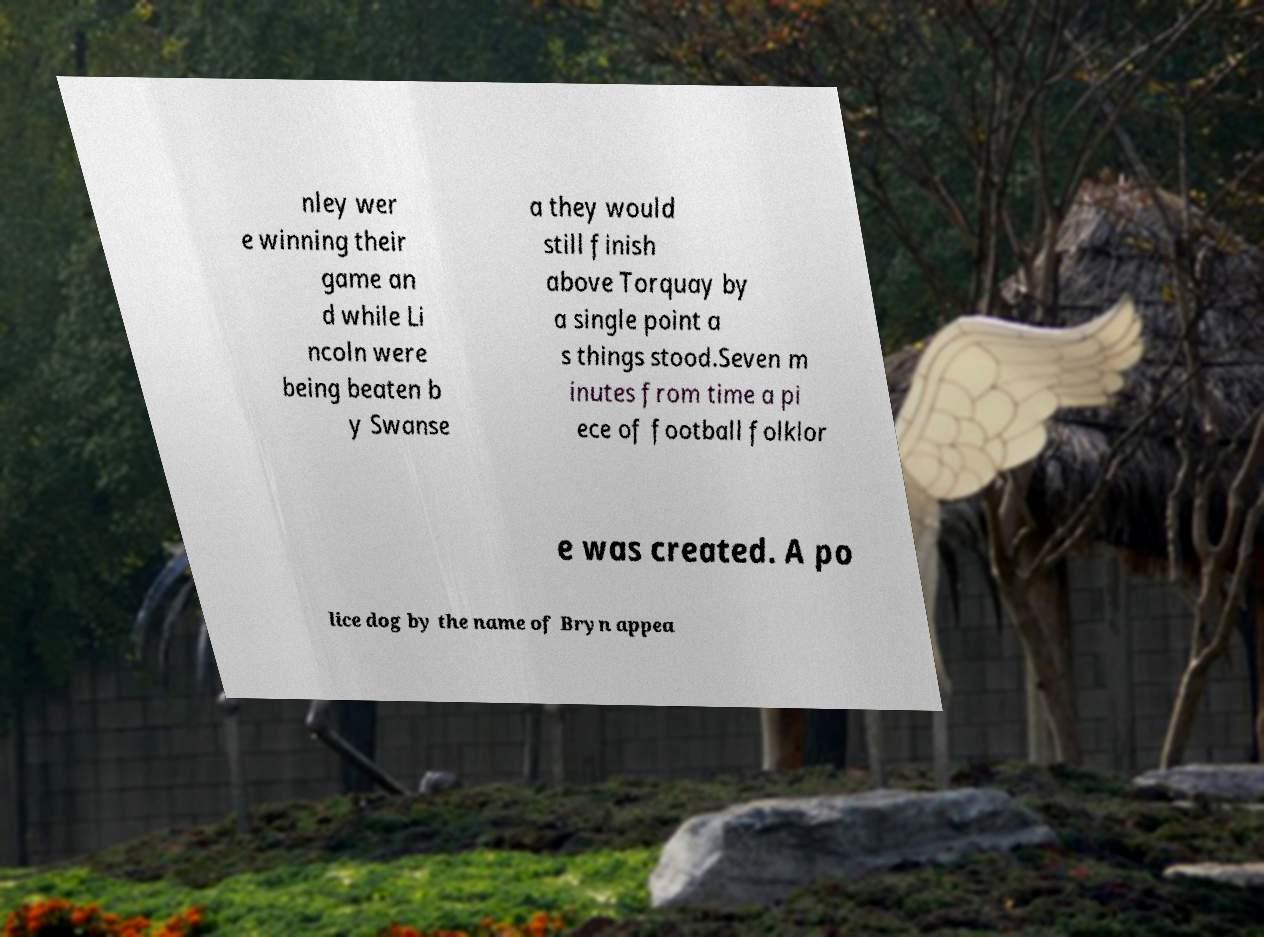Can you read and provide the text displayed in the image?This photo seems to have some interesting text. Can you extract and type it out for me? nley wer e winning their game an d while Li ncoln were being beaten b y Swanse a they would still finish above Torquay by a single point a s things stood.Seven m inutes from time a pi ece of football folklor e was created. A po lice dog by the name of Bryn appea 